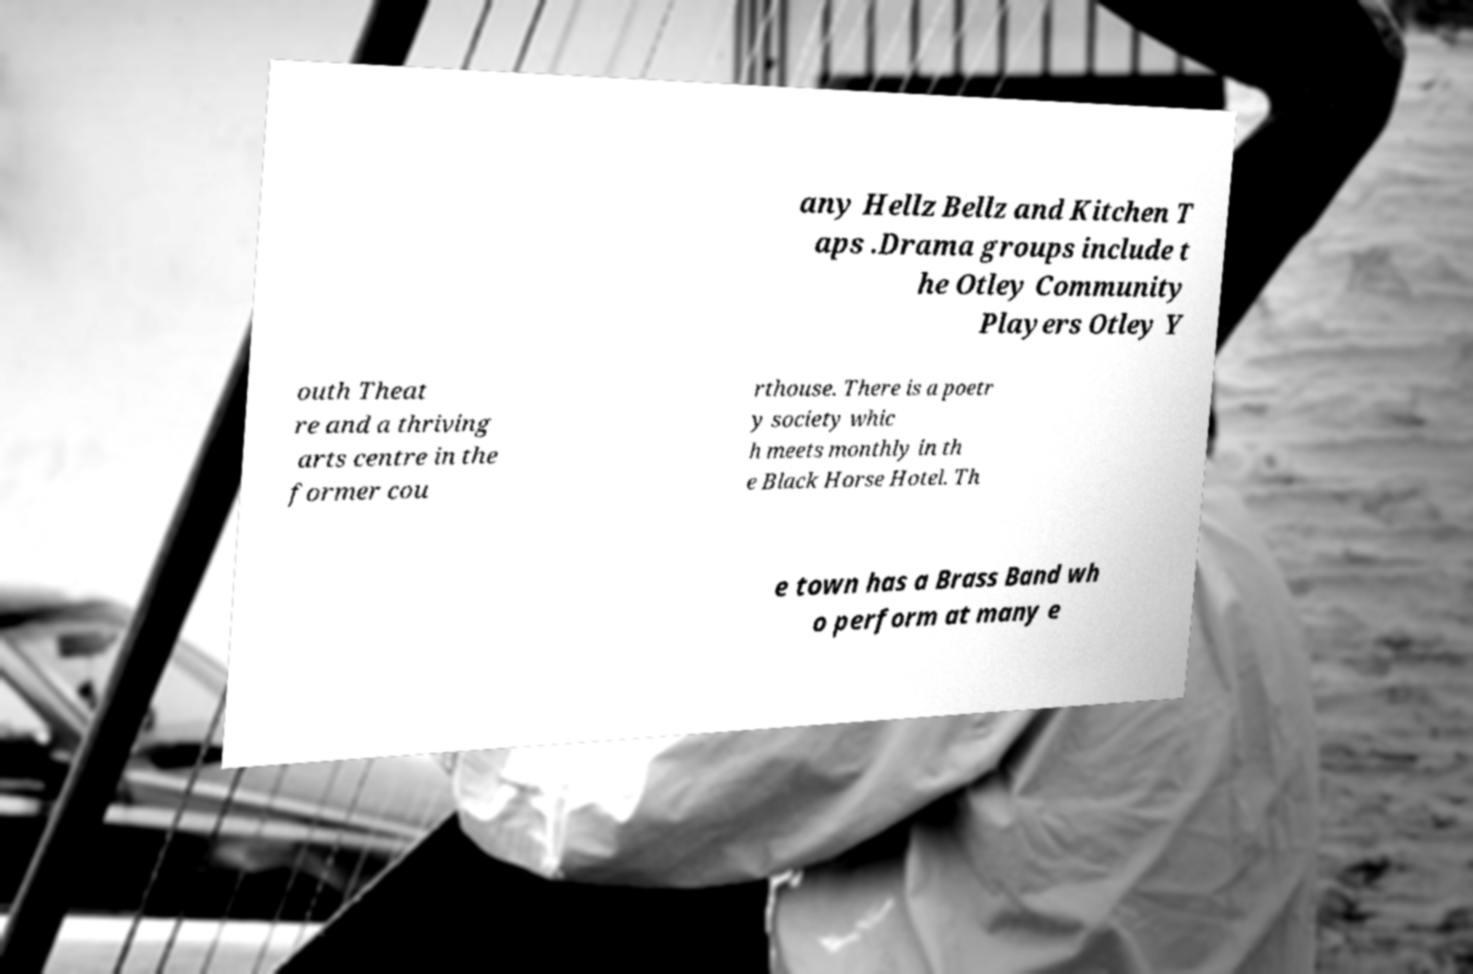I need the written content from this picture converted into text. Can you do that? any Hellz Bellz and Kitchen T aps .Drama groups include t he Otley Community Players Otley Y outh Theat re and a thriving arts centre in the former cou rthouse. There is a poetr y society whic h meets monthly in th e Black Horse Hotel. Th e town has a Brass Band wh o perform at many e 